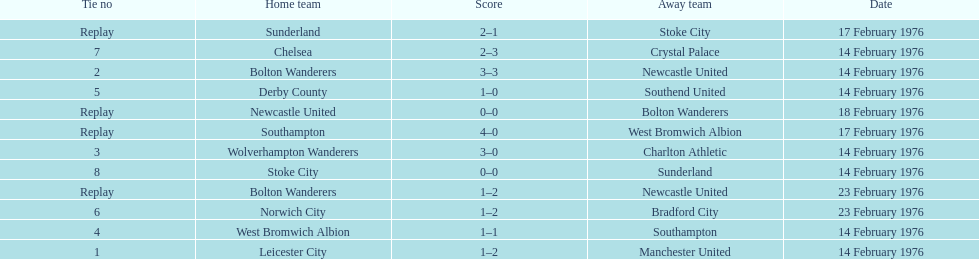What was the number of games that occurred on 14 february 1976? 7. 